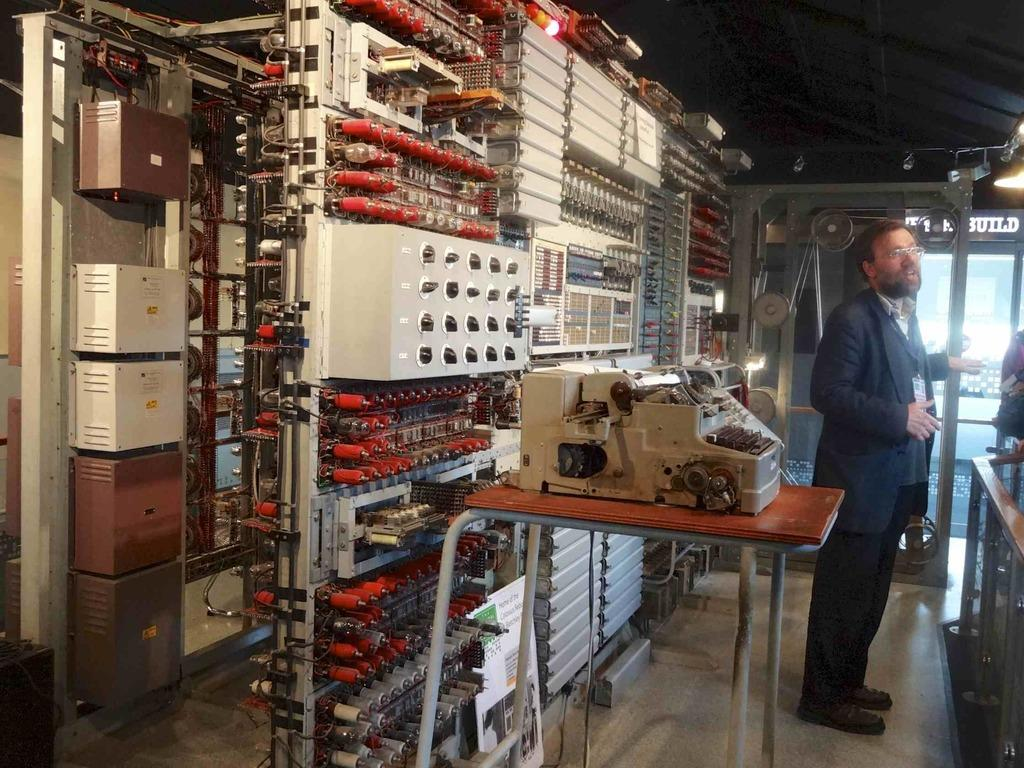What is the person in the image wearing? The person is wearing a black suit. What object can be seen on a table in the image? There is a typing machine on a table in the image. What type of items are present in the image besides the person and the typing machine? There are electronic devices and machines in the image. What type of flowers can be seen growing near the person in the image? There are no flowers visible in the image. 